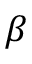<formula> <loc_0><loc_0><loc_500><loc_500>\beta</formula> 